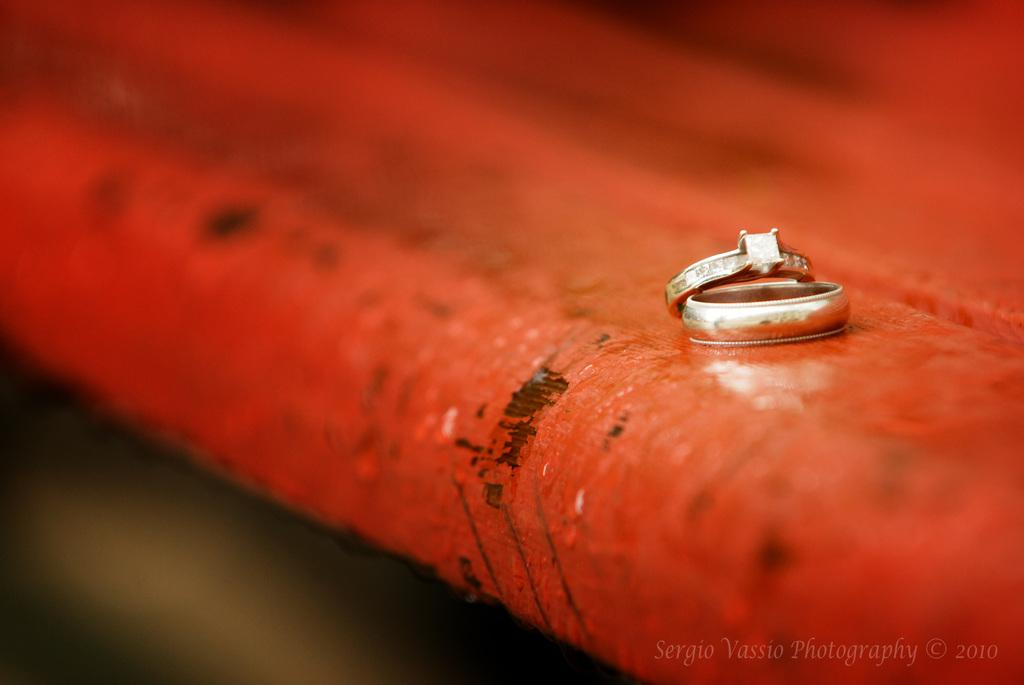What objects are on the red surface in the image? There are two rings on a red surface in the image. What can be observed about the background of the image? The background of the image is blurred. Is there any text present in the image? Yes, there is some text in the bottom right-hand corner of the image. What grade is the student receiving for their performance in the show in the image? There is no show or student present in the image, so it is not possible to determine a grade for a performance. 